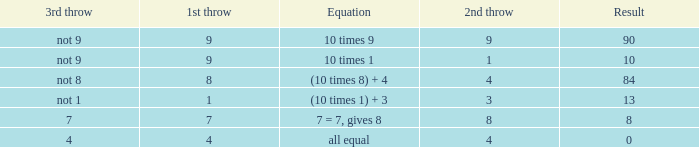If the equation is (10 times 8) + 4, what would be the 2nd throw? 4.0. 